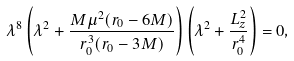<formula> <loc_0><loc_0><loc_500><loc_500>\lambda ^ { 8 } \left ( \lambda ^ { 2 } + \frac { M \mu ^ { 2 } ( r _ { 0 } - 6 M ) } { r _ { 0 } ^ { 3 } ( r _ { 0 } - 3 M ) } \right ) \left ( \lambda ^ { 2 } + \frac { L _ { z } ^ { 2 } } { r _ { 0 } ^ { 4 } } \right ) = 0 ,</formula> 